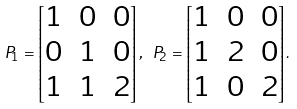Convert formula to latex. <formula><loc_0><loc_0><loc_500><loc_500>P _ { 1 } = \begin{bmatrix} 1 & 0 & 0 \\ 0 & 1 & 0 \\ 1 & 1 & 2 \end{bmatrix} , \ P _ { 2 } = \begin{bmatrix} 1 & 0 & 0 \\ 1 & 2 & 0 \\ 1 & 0 & 2 \end{bmatrix} .</formula> 